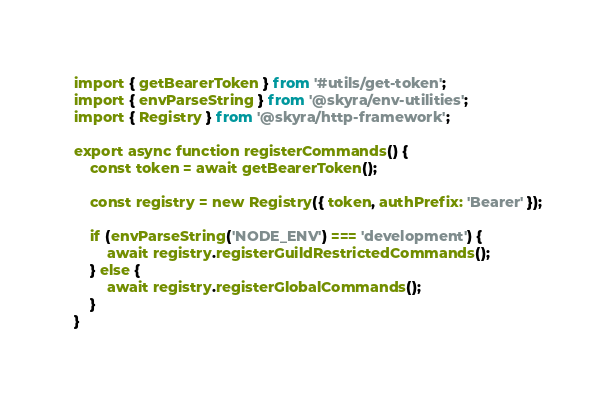Convert code to text. <code><loc_0><loc_0><loc_500><loc_500><_TypeScript_>import { getBearerToken } from '#utils/get-token';
import { envParseString } from '@skyra/env-utilities';
import { Registry } from '@skyra/http-framework';

export async function registerCommands() {
	const token = await getBearerToken();

	const registry = new Registry({ token, authPrefix: 'Bearer' });

	if (envParseString('NODE_ENV') === 'development') {
		await registry.registerGuildRestrictedCommands();
	} else {
		await registry.registerGlobalCommands();
	}
}
</code> 